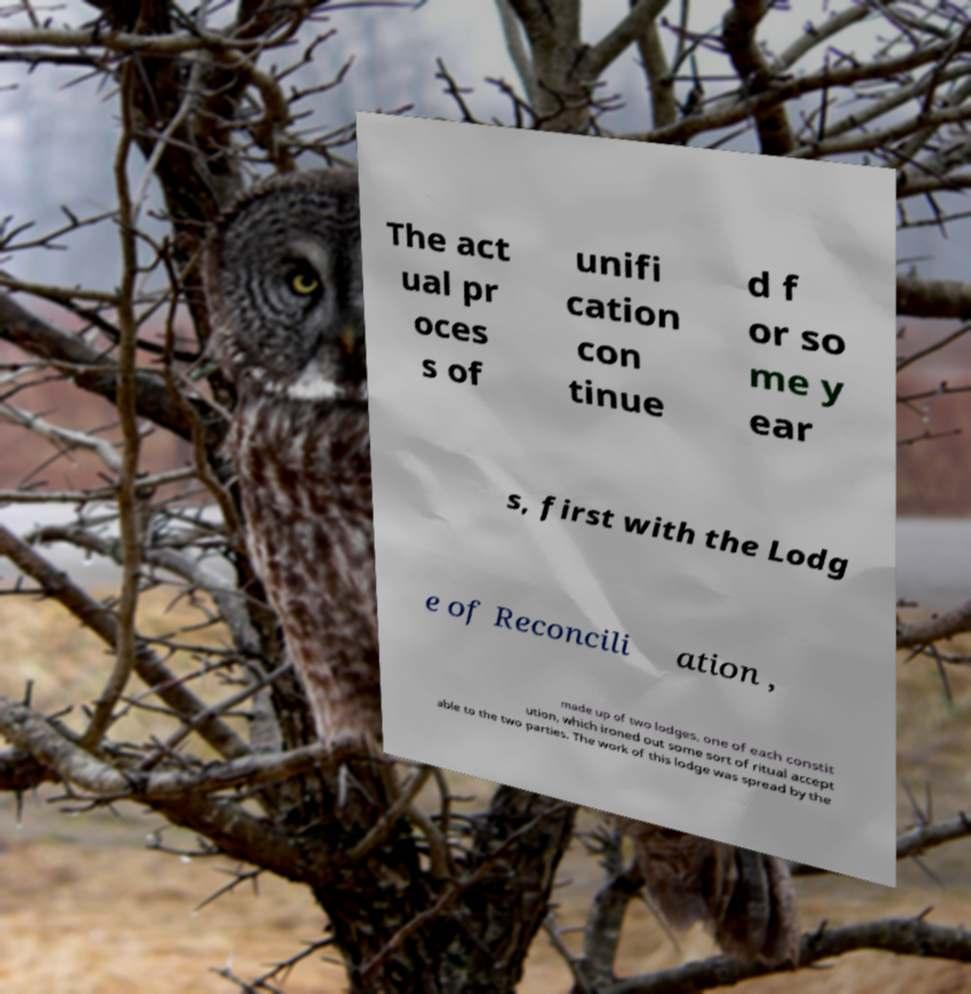Can you read and provide the text displayed in the image?This photo seems to have some interesting text. Can you extract and type it out for me? The act ual pr oces s of unifi cation con tinue d f or so me y ear s, first with the Lodg e of Reconcili ation , made up of two lodges, one of each constit ution, which ironed out some sort of ritual accept able to the two parties. The work of this lodge was spread by the 